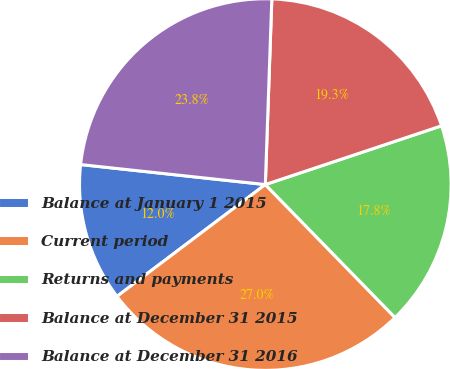Convert chart to OTSL. <chart><loc_0><loc_0><loc_500><loc_500><pie_chart><fcel>Balance at January 1 2015<fcel>Current period<fcel>Returns and payments<fcel>Balance at December 31 2015<fcel>Balance at December 31 2016<nl><fcel>12.0%<fcel>27.02%<fcel>17.82%<fcel>19.32%<fcel>23.84%<nl></chart> 